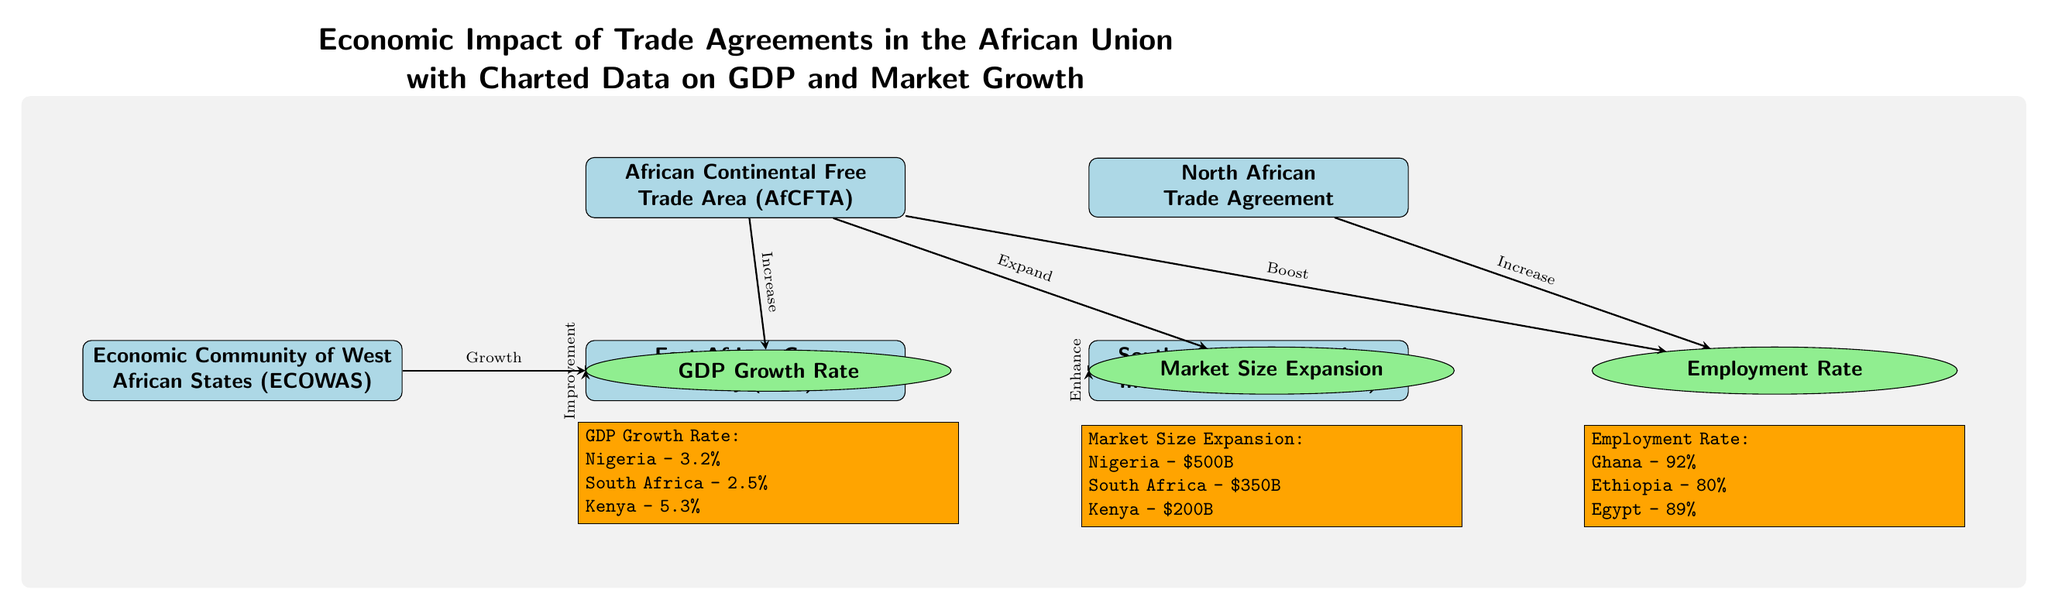What trade agreement is illustrated at the top of the diagram? The diagram displays the African Continental Free Trade Area, which is positioned prominently at the top.
Answer: African Continental Free Trade Area (AfCFTA) How many trade agreements are represented in the diagram? The total number of trade agreements listed in the diagram is five, as seen in the nodes for AfCFTA, ECOWAS, EAC, SADC, and the North African Trade Agreement.
Answer: 5 Which country has the highest GDP growth rate according to the diagram? The GDP growth rates are specified under the respective data point for GDP, and Kenya's rate of 5.3% is the highest among the listed countries.
Answer: Kenya - 5.3% What impact does the AfCFTA have on market size? The diagram shows that the AfCFTA contributes to the expansion of the market size as indicated by the arrow leading from AfCFTA to the Market Size Expansion node.
Answer: Expand What is the employment rate for Ghana as represented in the diagram? The employment rate for Ghana is specifically mentioned in the employment data section of the diagram, which states it is 92%.
Answer: 92% If South Africa's GDP growth rate is 2.5%, how does it compare to Nigeria's? The diagram shows Nigeria's GDP growth rate as 3.2%, which is higher than South Africa's 2.5%, indicating a comparative performance in GDP growth.
Answer: Higher Which agreement directly impacts employment according to the diagram? The diagram indicates that employment is influenced by the AfCFTA and the North African Trade Agreement, shown by the arrows leading to the Employment Rate node.
Answer: AfCFTA, North African Trade Agreement What is the market size for South Africa as depicted in the diagram? The market data section explicitly states that South Africa has a market size of $350 billion, which is a point of comparison with other countries listed.
Answer: $350B Which agreement shows the relationship "Enhance" to market size? The diagram illustrates an arrow from the Southern African Development Community (SADC) to the Market Size Expansion with the label "Enhance," indicating this relationship.
Answer: SADC 